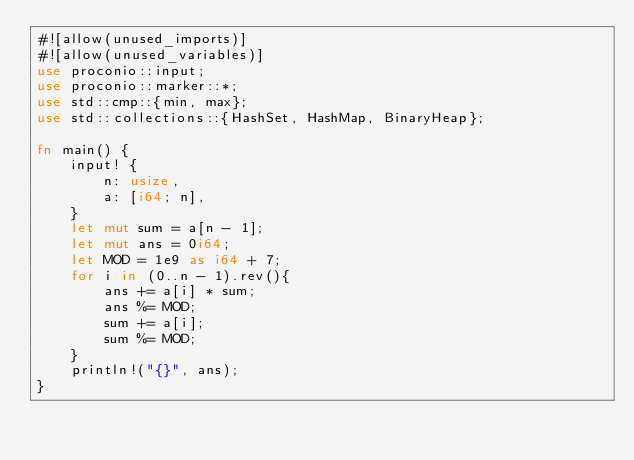<code> <loc_0><loc_0><loc_500><loc_500><_Rust_>#![allow(unused_imports)]
#![allow(unused_variables)]
use proconio::input;
use proconio::marker::*;
use std::cmp::{min, max};
use std::collections::{HashSet, HashMap, BinaryHeap};

fn main() {
    input! {
        n: usize,
        a: [i64; n],
    }
    let mut sum = a[n - 1];
    let mut ans = 0i64;
    let MOD = 1e9 as i64 + 7;
    for i in (0..n - 1).rev(){
        ans += a[i] * sum;
        ans %= MOD;
        sum += a[i];
        sum %= MOD;
    }
    println!("{}", ans);
}
</code> 